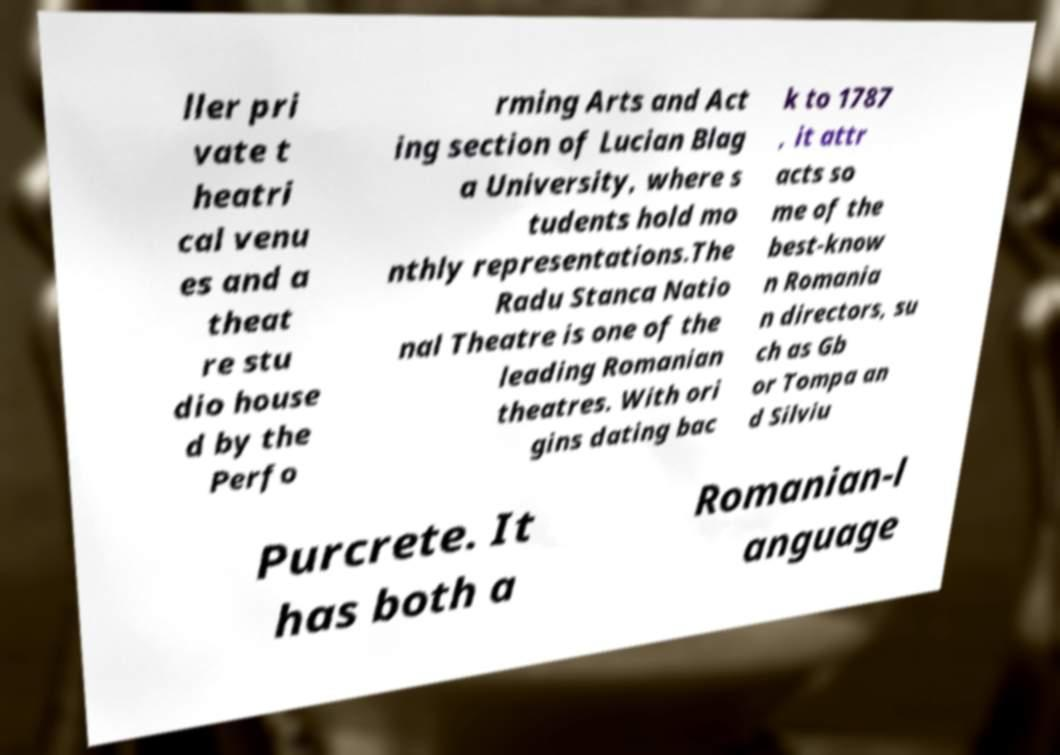Please read and relay the text visible in this image. What does it say? ller pri vate t heatri cal venu es and a theat re stu dio house d by the Perfo rming Arts and Act ing section of Lucian Blag a University, where s tudents hold mo nthly representations.The Radu Stanca Natio nal Theatre is one of the leading Romanian theatres. With ori gins dating bac k to 1787 , it attr acts so me of the best-know n Romania n directors, su ch as Gb or Tompa an d Silviu Purcrete. It has both a Romanian-l anguage 